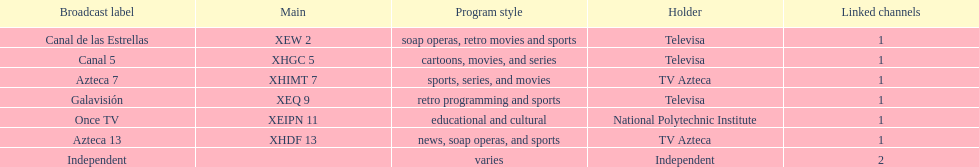How many affiliates does galavision have? 1. 